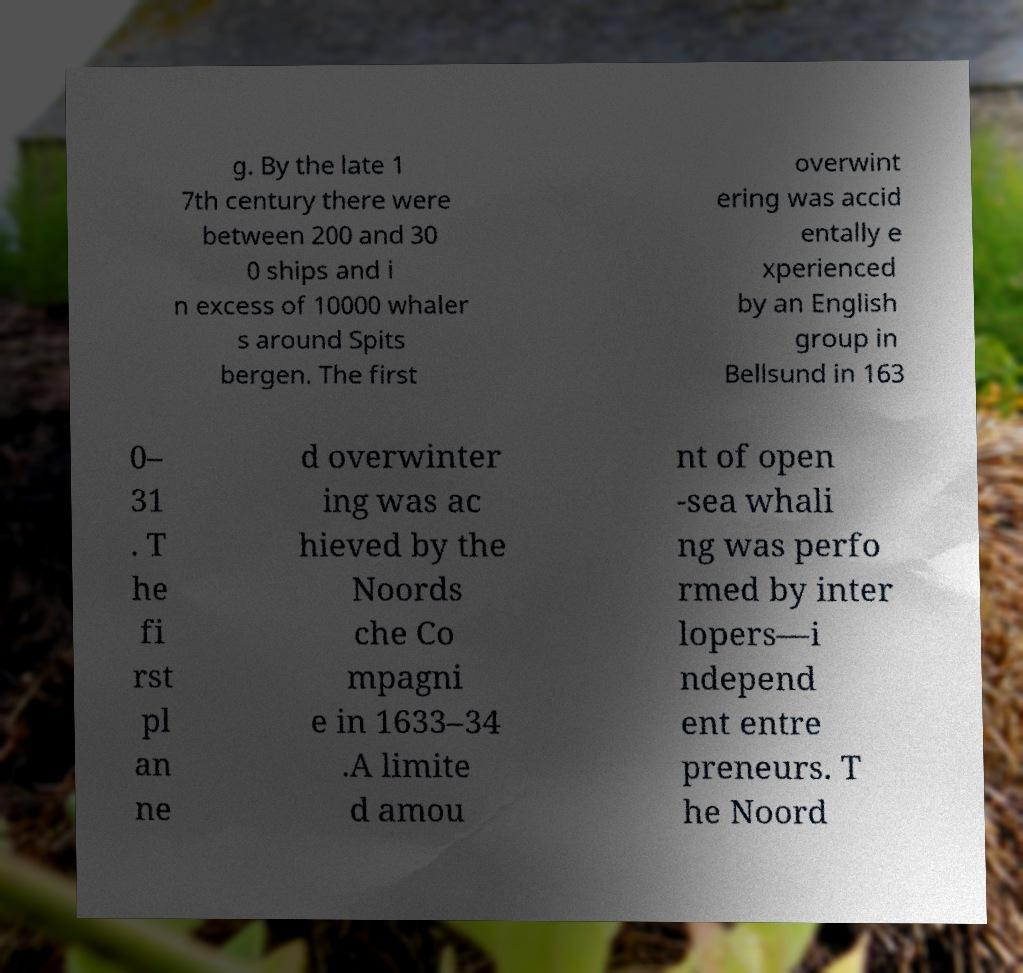Please identify and transcribe the text found in this image. g. By the late 1 7th century there were between 200 and 30 0 ships and i n excess of 10000 whaler s around Spits bergen. The first overwint ering was accid entally e xperienced by an English group in Bellsund in 163 0– 31 . T he fi rst pl an ne d overwinter ing was ac hieved by the Noords che Co mpagni e in 1633–34 .A limite d amou nt of open -sea whali ng was perfo rmed by inter lopers—i ndepend ent entre preneurs. T he Noord 